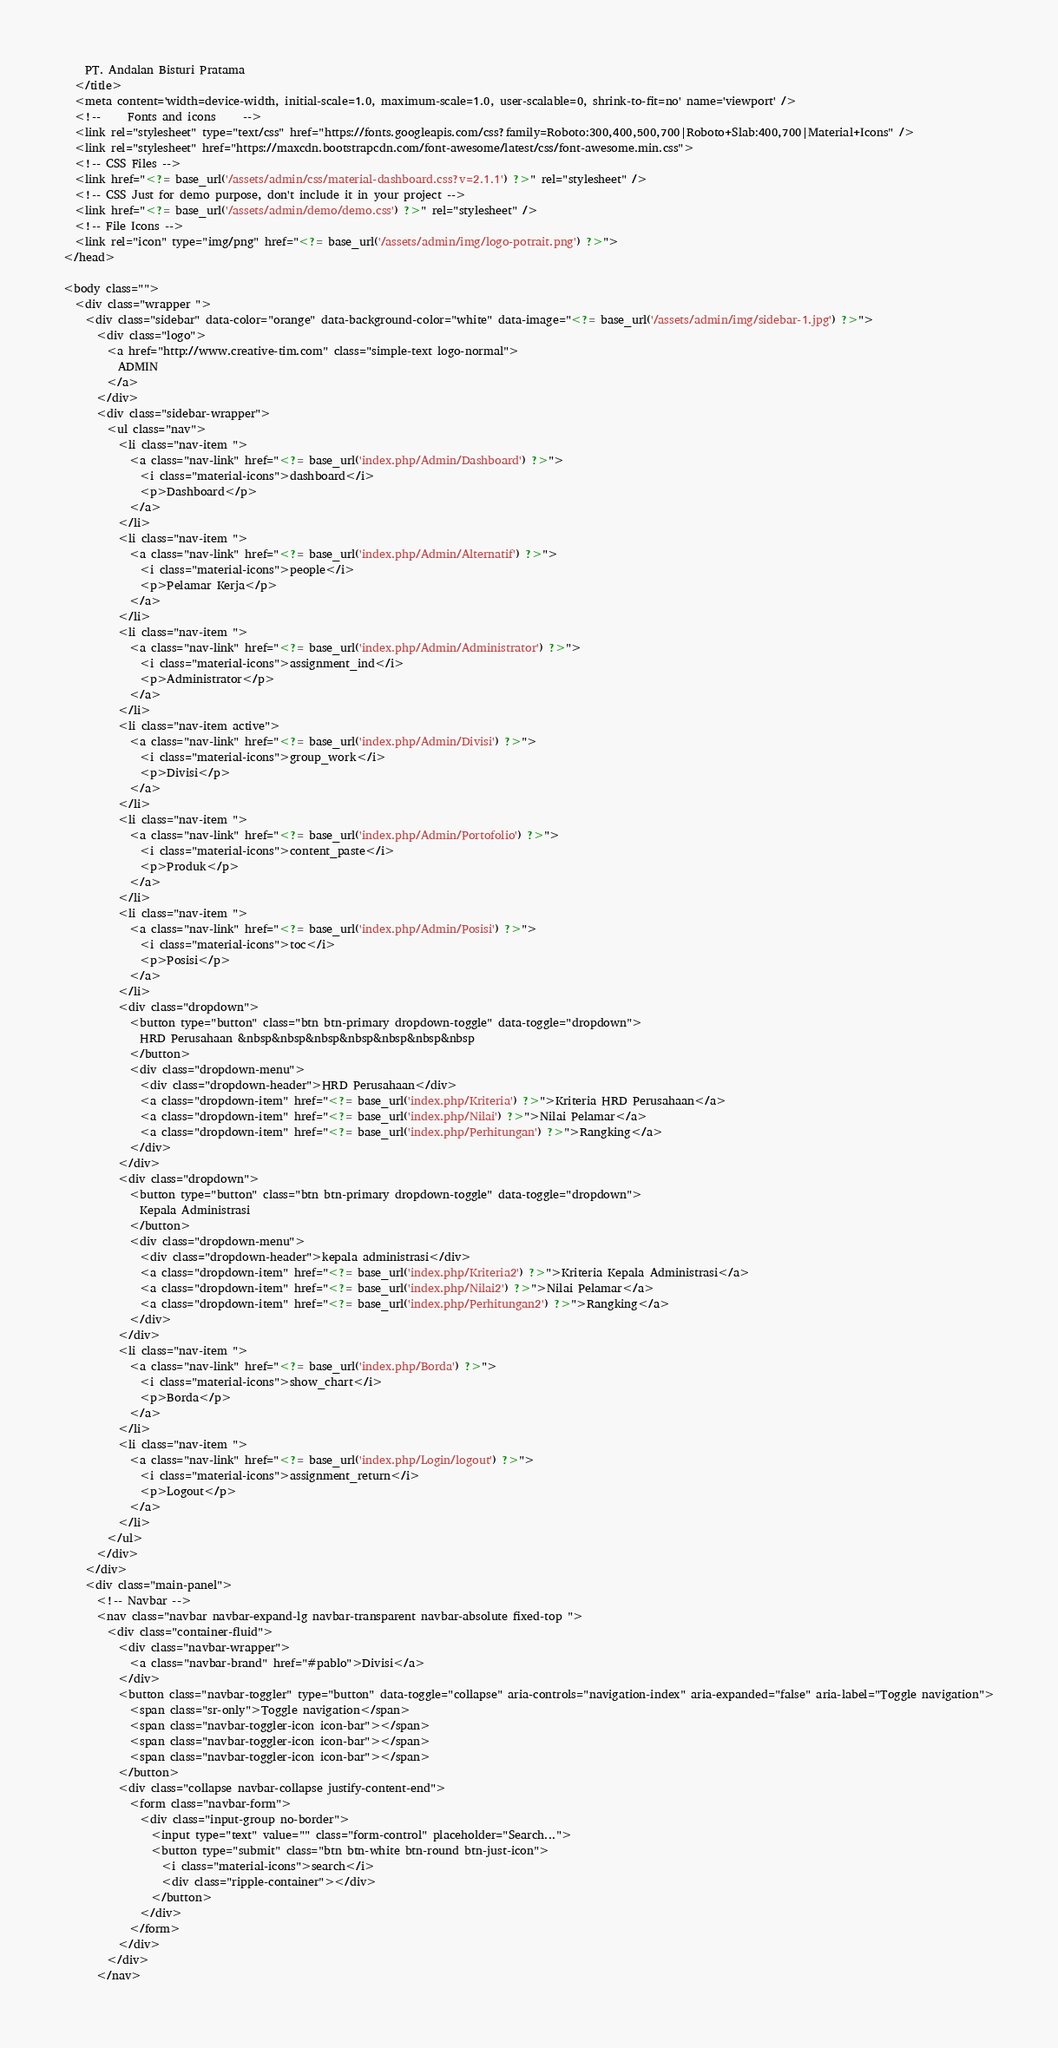Convert code to text. <code><loc_0><loc_0><loc_500><loc_500><_PHP_>    PT. Andalan Bisturi Pratama
  </title>
  <meta content='width=device-width, initial-scale=1.0, maximum-scale=1.0, user-scalable=0, shrink-to-fit=no' name='viewport' />
  <!--     Fonts and icons     -->
  <link rel="stylesheet" type="text/css" href="https://fonts.googleapis.com/css?family=Roboto:300,400,500,700|Roboto+Slab:400,700|Material+Icons" />
  <link rel="stylesheet" href="https://maxcdn.bootstrapcdn.com/font-awesome/latest/css/font-awesome.min.css">
  <!-- CSS Files -->
  <link href="<?= base_url('/assets/admin/css/material-dashboard.css?v=2.1.1') ?>" rel="stylesheet" />
  <!-- CSS Just for demo purpose, don't include it in your project -->
  <link href="<?= base_url('/assets/admin/demo/demo.css') ?>" rel="stylesheet" />
  <!-- File Icons -->
  <link rel="icon" type="img/png" href="<?= base_url('/assets/admin/img/logo-potrait.png') ?>">
</head>

<body class="">
  <div class="wrapper ">
    <div class="sidebar" data-color="orange" data-background-color="white" data-image="<?= base_url('/assets/admin/img/sidebar-1.jpg') ?>">
      <div class="logo">
        <a href="http://www.creative-tim.com" class="simple-text logo-normal">
          ADMIN
        </a>
      </div>
      <div class="sidebar-wrapper">
        <ul class="nav">
          <li class="nav-item ">
            <a class="nav-link" href="<?= base_url('index.php/Admin/Dashboard') ?>">
              <i class="material-icons">dashboard</i>
              <p>Dashboard</p>
            </a>
          </li>
          <li class="nav-item ">
            <a class="nav-link" href="<?= base_url('index.php/Admin/Alternatif') ?>">
              <i class="material-icons">people</i>
              <p>Pelamar Kerja</p>
            </a>
          </li>
          <li class="nav-item ">
            <a class="nav-link" href="<?= base_url('index.php/Admin/Administrator') ?>">
              <i class="material-icons">assignment_ind</i>
              <p>Administrator</p>
            </a>
          </li>
          <li class="nav-item active">
            <a class="nav-link" href="<?= base_url('index.php/Admin/Divisi') ?>">
              <i class="material-icons">group_work</i>
              <p>Divisi</p>
            </a>
          </li>
          <li class="nav-item ">
            <a class="nav-link" href="<?= base_url('index.php/Admin/Portofolio') ?>">
              <i class="material-icons">content_paste</i>
              <p>Produk</p>
            </a>
          </li>
          <li class="nav-item ">
            <a class="nav-link" href="<?= base_url('index.php/Admin/Posisi') ?>">
              <i class="material-icons">toc</i>
              <p>Posisi</p>
            </a>
          </li>
          <div class="dropdown">
            <button type="button" class="btn btn-primary dropdown-toggle" data-toggle="dropdown">
              HRD Perusahaan &nbsp&nbsp&nbsp&nbsp&nbsp&nbsp&nbsp
            </button>
            <div class="dropdown-menu">
              <div class="dropdown-header">HRD Perusahaan</div>
              <a class="dropdown-item" href="<?= base_url('index.php/Kriteria') ?>">Kriteria HRD Perusahaan</a>
              <a class="dropdown-item" href="<?= base_url('index.php/Nilai') ?>">Nilai Pelamar</a>
              <a class="dropdown-item" href="<?= base_url('index.php/Perhitungan') ?>">Rangking</a>
            </div>
          </div>  
          <div class="dropdown">
            <button type="button" class="btn btn-primary dropdown-toggle" data-toggle="dropdown">
              Kepala Administrasi
            </button>
            <div class="dropdown-menu">
              <div class="dropdown-header">kepala administrasi</div>
              <a class="dropdown-item" href="<?= base_url('index.php/Kriteria2') ?>">Kriteria Kepala Administrasi</a>
              <a class="dropdown-item" href="<?= base_url('index.php/Nilai2') ?>">Nilai Pelamar</a>
              <a class="dropdown-item" href="<?= base_url('index.php/Perhitungan2') ?>">Rangking</a>
            </div>
          </div>
          <li class="nav-item ">
            <a class="nav-link" href="<?= base_url('index.php/Borda') ?>">
              <i class="material-icons">show_chart</i>
              <p>Borda</p>
            </a>
          </li>
          <li class="nav-item ">
            <a class="nav-link" href="<?= base_url('index.php/Login/logout') ?>">
              <i class="material-icons">assignment_return</i>
              <p>Logout</p>
            </a>
          </li>
        </ul>
      </div>
    </div>
    <div class="main-panel">
      <!-- Navbar -->
      <nav class="navbar navbar-expand-lg navbar-transparent navbar-absolute fixed-top ">
        <div class="container-fluid">
          <div class="navbar-wrapper">
            <a class="navbar-brand" href="#pablo">Divisi</a>
          </div>
          <button class="navbar-toggler" type="button" data-toggle="collapse" aria-controls="navigation-index" aria-expanded="false" aria-label="Toggle navigation">
            <span class="sr-only">Toggle navigation</span>
            <span class="navbar-toggler-icon icon-bar"></span>
            <span class="navbar-toggler-icon icon-bar"></span>
            <span class="navbar-toggler-icon icon-bar"></span>
          </button>
          <div class="collapse navbar-collapse justify-content-end">
            <form class="navbar-form">
              <div class="input-group no-border">
                <input type="text" value="" class="form-control" placeholder="Search...">
                <button type="submit" class="btn btn-white btn-round btn-just-icon">
                  <i class="material-icons">search</i>
                  <div class="ripple-container"></div>
                </button>
              </div>
            </form>
          </div>
        </div>
      </nav>
</code> 